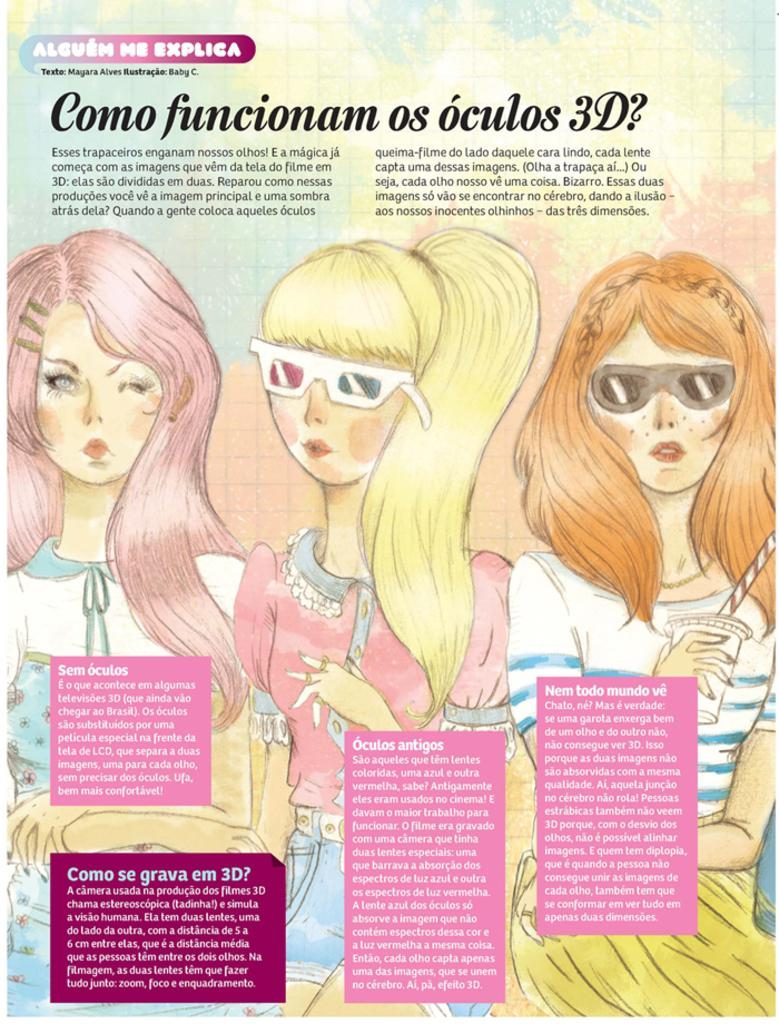How many people are in the image? There are three girls in the image. What are the girls doing in the image? The girls are standing. Which girl is holding a glass with a straw? One girl is holding a glass with a straw. What else can be seen in the image besides the girls? There is text present in the image. What type of trains can be seen in the image? There are no trains present in the image. Can you describe the bite marks on the glass with a straw? There are no bite marks visible on the glass with a straw in the image. 